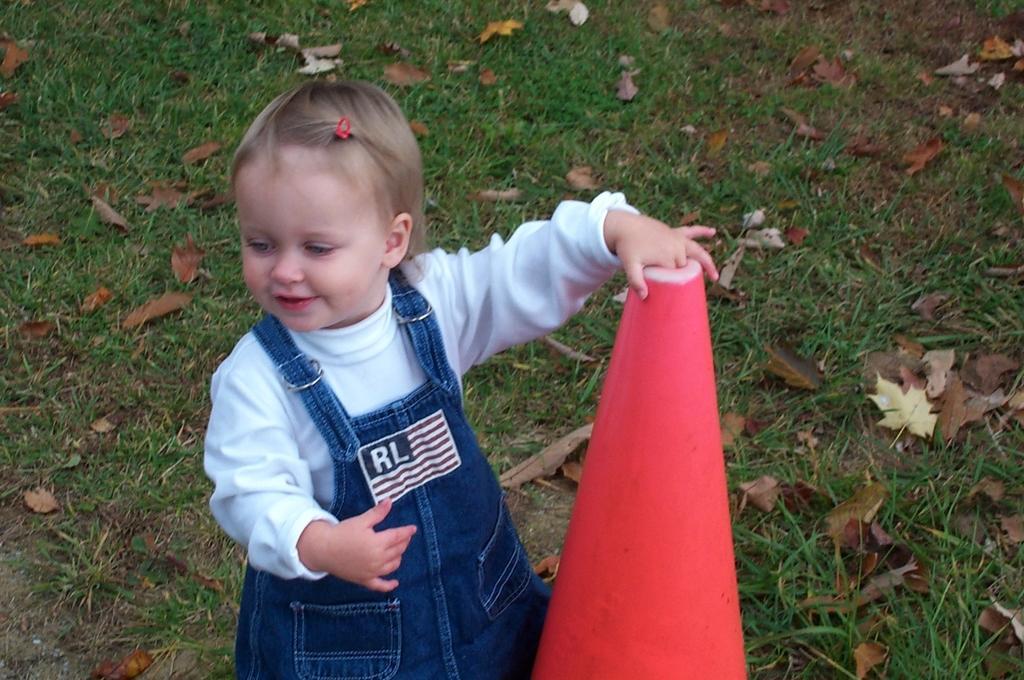Could you give a brief overview of what you see in this image? In this picture I can observe a girl standing on the ground. She is wearing blue and white color dress. I can observe dried leaves on the ground. There is a pink color cone placed on the ground, on the right side. 